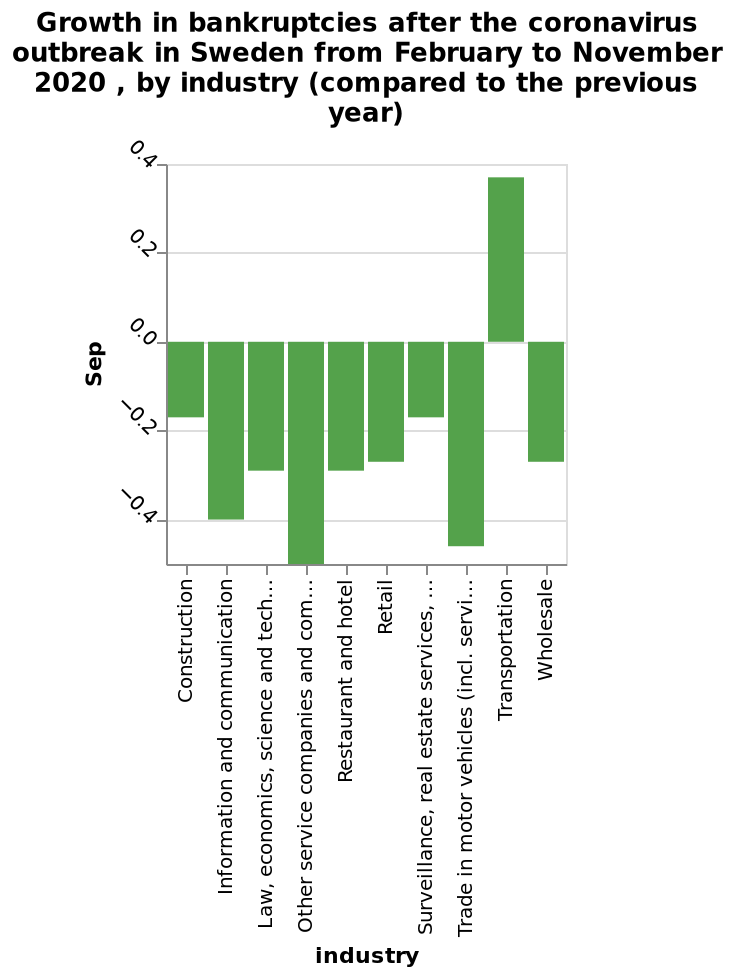<image>
What is the unique aspect of transport during Covid? Transport is the only industry that remains profitable and positive during Covid. 